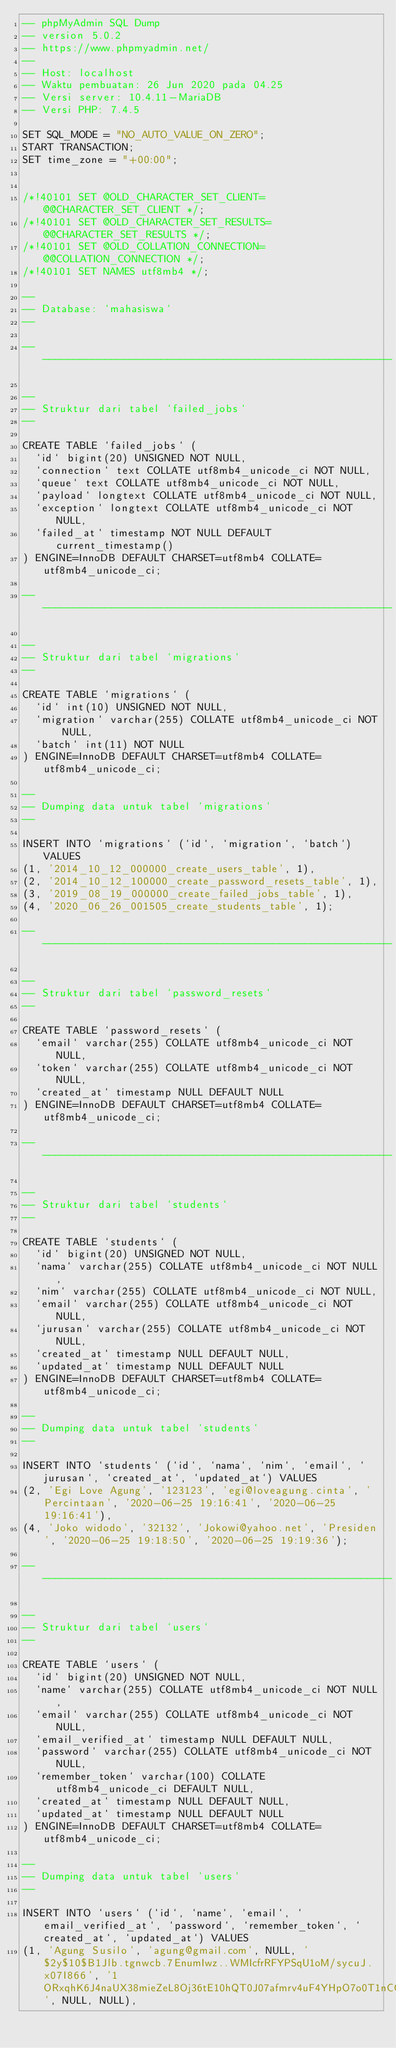Convert code to text. <code><loc_0><loc_0><loc_500><loc_500><_SQL_>-- phpMyAdmin SQL Dump
-- version 5.0.2
-- https://www.phpmyadmin.net/
--
-- Host: localhost
-- Waktu pembuatan: 26 Jun 2020 pada 04.25
-- Versi server: 10.4.11-MariaDB
-- Versi PHP: 7.4.5

SET SQL_MODE = "NO_AUTO_VALUE_ON_ZERO";
START TRANSACTION;
SET time_zone = "+00:00";


/*!40101 SET @OLD_CHARACTER_SET_CLIENT=@@CHARACTER_SET_CLIENT */;
/*!40101 SET @OLD_CHARACTER_SET_RESULTS=@@CHARACTER_SET_RESULTS */;
/*!40101 SET @OLD_COLLATION_CONNECTION=@@COLLATION_CONNECTION */;
/*!40101 SET NAMES utf8mb4 */;

--
-- Database: `mahasiswa`
--

-- --------------------------------------------------------

--
-- Struktur dari tabel `failed_jobs`
--

CREATE TABLE `failed_jobs` (
  `id` bigint(20) UNSIGNED NOT NULL,
  `connection` text COLLATE utf8mb4_unicode_ci NOT NULL,
  `queue` text COLLATE utf8mb4_unicode_ci NOT NULL,
  `payload` longtext COLLATE utf8mb4_unicode_ci NOT NULL,
  `exception` longtext COLLATE utf8mb4_unicode_ci NOT NULL,
  `failed_at` timestamp NOT NULL DEFAULT current_timestamp()
) ENGINE=InnoDB DEFAULT CHARSET=utf8mb4 COLLATE=utf8mb4_unicode_ci;

-- --------------------------------------------------------

--
-- Struktur dari tabel `migrations`
--

CREATE TABLE `migrations` (
  `id` int(10) UNSIGNED NOT NULL,
  `migration` varchar(255) COLLATE utf8mb4_unicode_ci NOT NULL,
  `batch` int(11) NOT NULL
) ENGINE=InnoDB DEFAULT CHARSET=utf8mb4 COLLATE=utf8mb4_unicode_ci;

--
-- Dumping data untuk tabel `migrations`
--

INSERT INTO `migrations` (`id`, `migration`, `batch`) VALUES
(1, '2014_10_12_000000_create_users_table', 1),
(2, '2014_10_12_100000_create_password_resets_table', 1),
(3, '2019_08_19_000000_create_failed_jobs_table', 1),
(4, '2020_06_26_001505_create_students_table', 1);

-- --------------------------------------------------------

--
-- Struktur dari tabel `password_resets`
--

CREATE TABLE `password_resets` (
  `email` varchar(255) COLLATE utf8mb4_unicode_ci NOT NULL,
  `token` varchar(255) COLLATE utf8mb4_unicode_ci NOT NULL,
  `created_at` timestamp NULL DEFAULT NULL
) ENGINE=InnoDB DEFAULT CHARSET=utf8mb4 COLLATE=utf8mb4_unicode_ci;

-- --------------------------------------------------------

--
-- Struktur dari tabel `students`
--

CREATE TABLE `students` (
  `id` bigint(20) UNSIGNED NOT NULL,
  `nama` varchar(255) COLLATE utf8mb4_unicode_ci NOT NULL,
  `nim` varchar(255) COLLATE utf8mb4_unicode_ci NOT NULL,
  `email` varchar(255) COLLATE utf8mb4_unicode_ci NOT NULL,
  `jurusan` varchar(255) COLLATE utf8mb4_unicode_ci NOT NULL,
  `created_at` timestamp NULL DEFAULT NULL,
  `updated_at` timestamp NULL DEFAULT NULL
) ENGINE=InnoDB DEFAULT CHARSET=utf8mb4 COLLATE=utf8mb4_unicode_ci;

--
-- Dumping data untuk tabel `students`
--

INSERT INTO `students` (`id`, `nama`, `nim`, `email`, `jurusan`, `created_at`, `updated_at`) VALUES
(2, 'Egi Love Agung', '123123', 'egi@loveagung.cinta', 'Percintaan', '2020-06-25 19:16:41', '2020-06-25 19:16:41'),
(4, 'Joko widodo', '32132', 'Jokowi@yahoo.net', 'Presiden', '2020-06-25 19:18:50', '2020-06-25 19:19:36');

-- --------------------------------------------------------

--
-- Struktur dari tabel `users`
--

CREATE TABLE `users` (
  `id` bigint(20) UNSIGNED NOT NULL,
  `name` varchar(255) COLLATE utf8mb4_unicode_ci NOT NULL,
  `email` varchar(255) COLLATE utf8mb4_unicode_ci NOT NULL,
  `email_verified_at` timestamp NULL DEFAULT NULL,
  `password` varchar(255) COLLATE utf8mb4_unicode_ci NOT NULL,
  `remember_token` varchar(100) COLLATE utf8mb4_unicode_ci DEFAULT NULL,
  `created_at` timestamp NULL DEFAULT NULL,
  `updated_at` timestamp NULL DEFAULT NULL
) ENGINE=InnoDB DEFAULT CHARSET=utf8mb4 COLLATE=utf8mb4_unicode_ci;

--
-- Dumping data untuk tabel `users`
--

INSERT INTO `users` (`id`, `name`, `email`, `email_verified_at`, `password`, `remember_token`, `created_at`, `updated_at`) VALUES
(1, 'Agung Susilo', 'agung@gmail.com', NULL, '$2y$10$B1Jlb.tgnwcb.7EnumIwz..WMIcfrRFYPSqU1oM/sycuJ.x07I866', '1ORxqhK6J4naUX38mieZeL8Oj36tE10hQT0J07afmrv4uF4YHpO7o0T1nCQO', NULL, NULL),</code> 